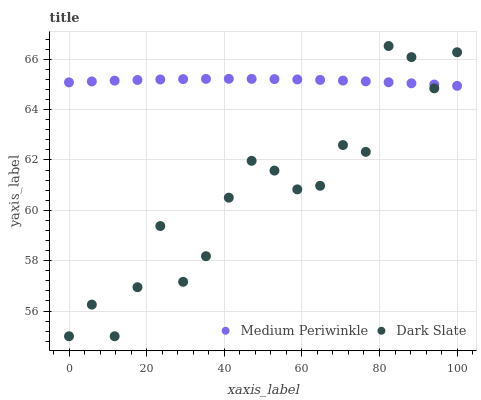Does Dark Slate have the minimum area under the curve?
Answer yes or no. Yes. Does Medium Periwinkle have the maximum area under the curve?
Answer yes or no. Yes. Does Medium Periwinkle have the minimum area under the curve?
Answer yes or no. No. Is Medium Periwinkle the smoothest?
Answer yes or no. Yes. Is Dark Slate the roughest?
Answer yes or no. Yes. Is Medium Periwinkle the roughest?
Answer yes or no. No. Does Dark Slate have the lowest value?
Answer yes or no. Yes. Does Medium Periwinkle have the lowest value?
Answer yes or no. No. Does Dark Slate have the highest value?
Answer yes or no. Yes. Does Medium Periwinkle have the highest value?
Answer yes or no. No. Does Dark Slate intersect Medium Periwinkle?
Answer yes or no. Yes. Is Dark Slate less than Medium Periwinkle?
Answer yes or no. No. Is Dark Slate greater than Medium Periwinkle?
Answer yes or no. No. 